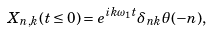<formula> <loc_0><loc_0><loc_500><loc_500>X _ { n , k } ( t \leq 0 ) = e ^ { i k \omega _ { 1 } t } \delta _ { n k } \theta ( - n ) ,</formula> 